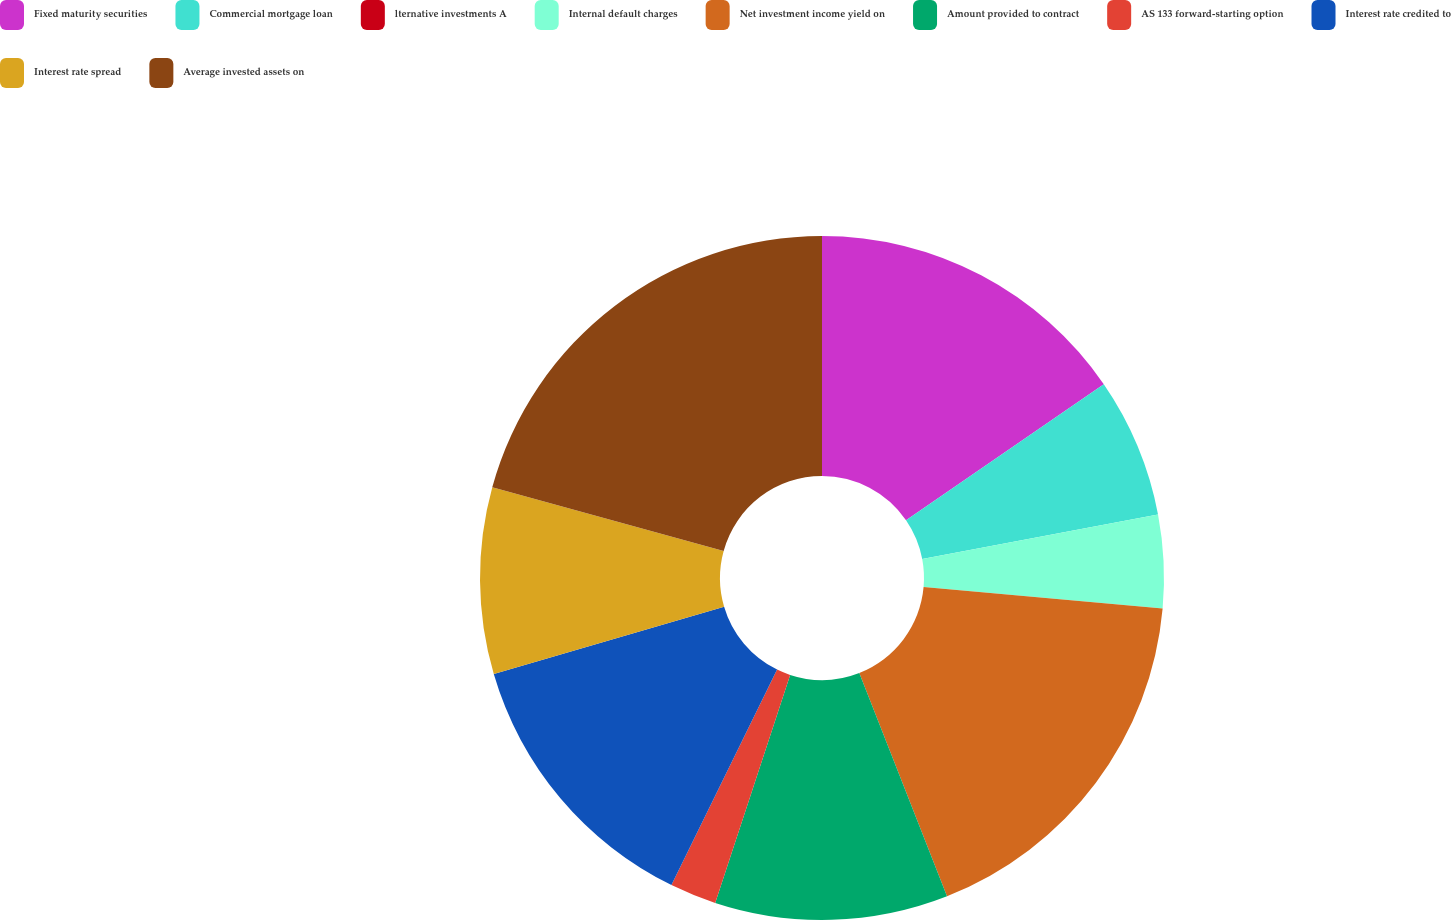Convert chart to OTSL. <chart><loc_0><loc_0><loc_500><loc_500><pie_chart><fcel>Fixed maturity securities<fcel>Commercial mortgage loan<fcel>lternative investments A<fcel>Internal default charges<fcel>Net investment income yield on<fcel>Amount provided to contract<fcel>AS 133 forward-starting option<fcel>Interest rate credited to<fcel>Interest rate spread<fcel>Average invested assets on<nl><fcel>15.41%<fcel>6.61%<fcel>0.0%<fcel>4.4%<fcel>17.62%<fcel>11.01%<fcel>2.2%<fcel>13.21%<fcel>8.81%<fcel>20.72%<nl></chart> 